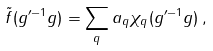Convert formula to latex. <formula><loc_0><loc_0><loc_500><loc_500>\tilde { f } ( g ^ { \prime - 1 } g ) = \sum _ { q } a _ { q } \chi _ { q } ( g ^ { \prime - 1 } g ) \, ,</formula> 